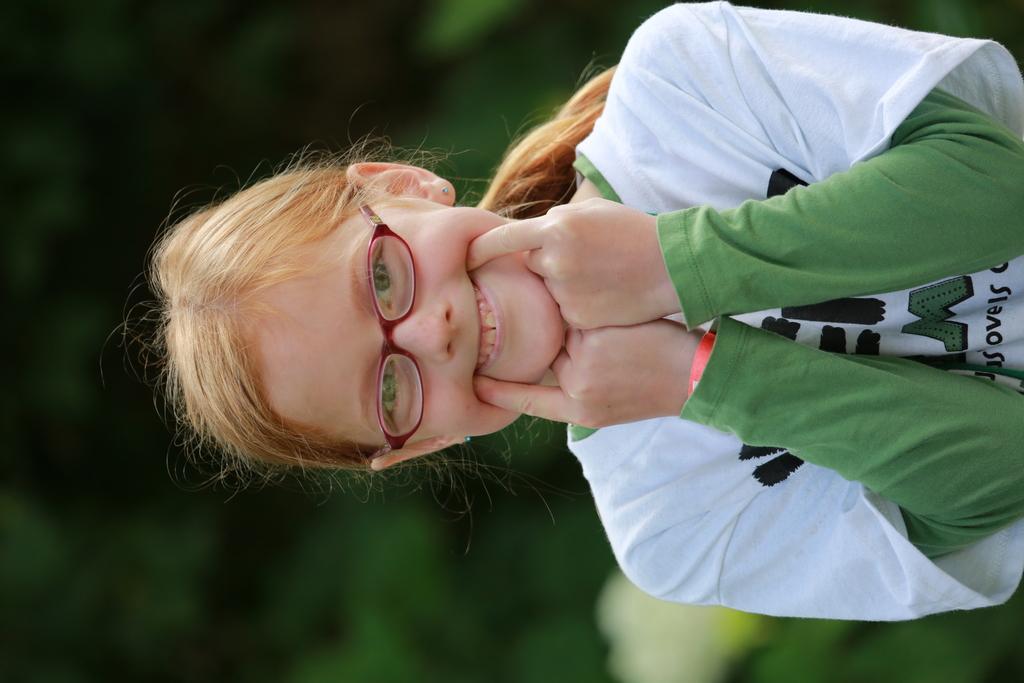How would you summarize this image in a sentence or two? In this picture, we can see as girl and the background is blurred. 